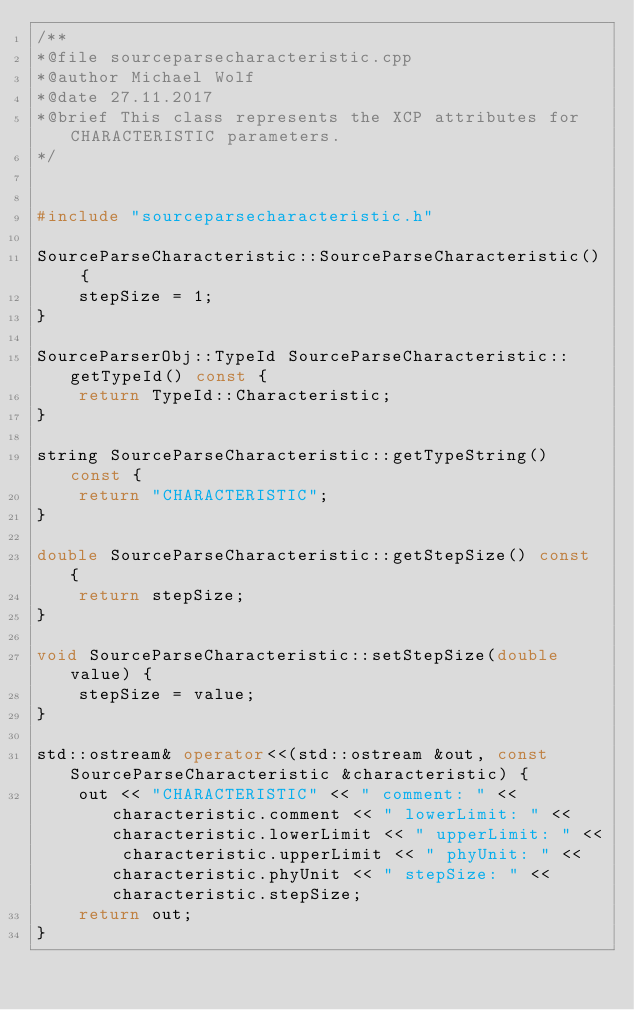<code> <loc_0><loc_0><loc_500><loc_500><_C++_>/**
*@file sourceparsecharacteristic.cpp
*@author Michael Wolf
*@date 27.11.2017
*@brief This class represents the XCP attributes for CHARACTERISTIC parameters.
*/


#include "sourceparsecharacteristic.h"

SourceParseCharacteristic::SourceParseCharacteristic() {
    stepSize = 1;
}

SourceParserObj::TypeId SourceParseCharacteristic::getTypeId() const {
    return TypeId::Characteristic;
}

string SourceParseCharacteristic::getTypeString() const {
    return "CHARACTERISTIC";
}

double SourceParseCharacteristic::getStepSize() const {
    return stepSize;
}

void SourceParseCharacteristic::setStepSize(double value) {
    stepSize = value;
}

std::ostream& operator<<(std::ostream &out, const SourceParseCharacteristic &characteristic) {
    out << "CHARACTERISTIC" << " comment: " << characteristic.comment << " lowerLimit: " << characteristic.lowerLimit << " upperLimit: " << characteristic.upperLimit << " phyUnit: " << characteristic.phyUnit << " stepSize: " << characteristic.stepSize;
    return out;
}
</code> 